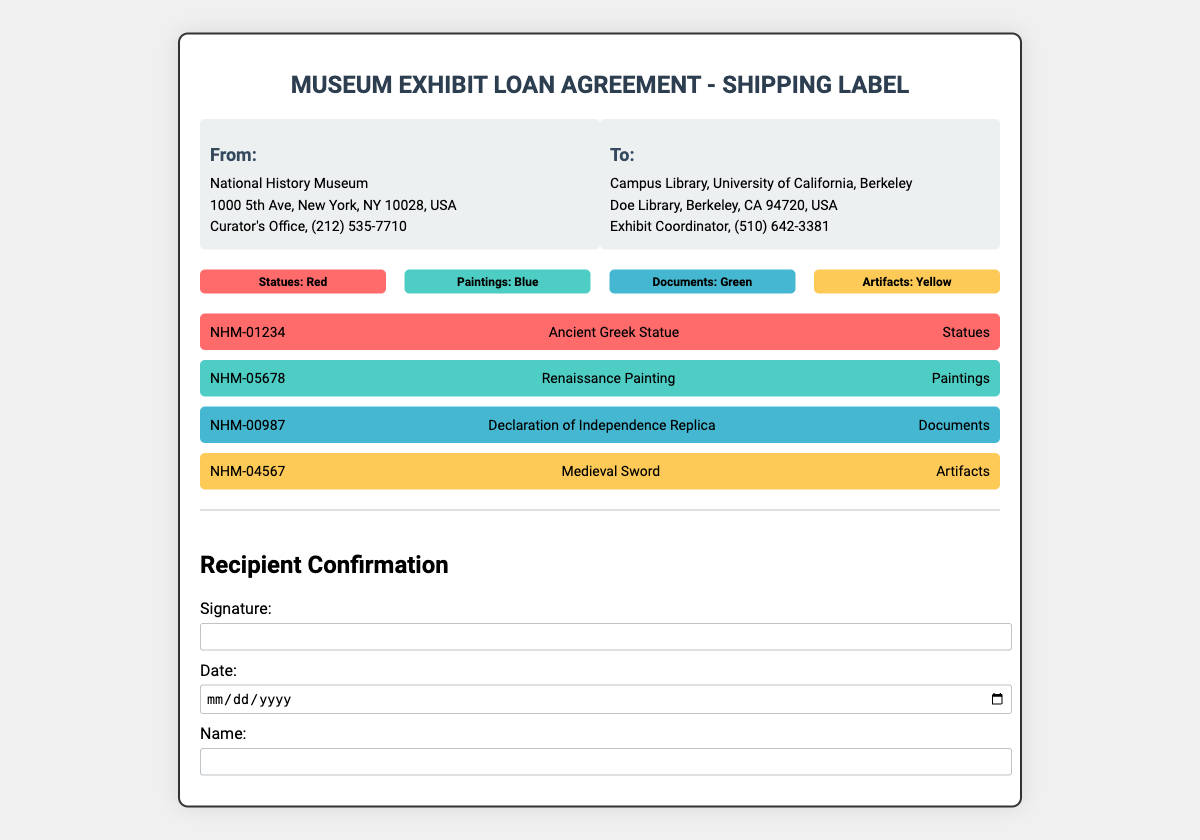What is the address of the sender? The sender's address is found in the "From" section of the shipping label, which provides the address of the National History Museum.
Answer: 1000 5th Ave, New York, NY 10028, USA How many items are listed in the shipping label? The document lists a total of four items, indicating the number of different exhibits being sent.
Answer: 4 What color represents artifacts? The color-coding section indicates each category by color, with yellow specifically assigned to artifacts.
Answer: Yellow What is the phone number for the recipient? The recipient's phone number is stated under the "To" section of the label, providing contact information for the Exhibit Coordinator.
Answer: (510) 642-3381 What type of item is NHM-00987? The item ID is associated with a specific exhibit, and the document specifies that NHM-00987 corresponds to a document category.
Answer: Declaration of Independence Replica What is required in the recipient confirmation section for completion? The document outlines specific information needed for the recipient to confirm receipt of the items, which includes signature, date, and name.
Answer: Signature, Date, Name Which museum is sending the exhibit? The shipping label details identify the sender's organization under the "From" section, clearly naming the museum involved in the shipment.
Answer: National History Museum What type of object is represented in the red color-coding? Color coding indicates the category of items, with red designating statues specifically.
Answer: Statues 